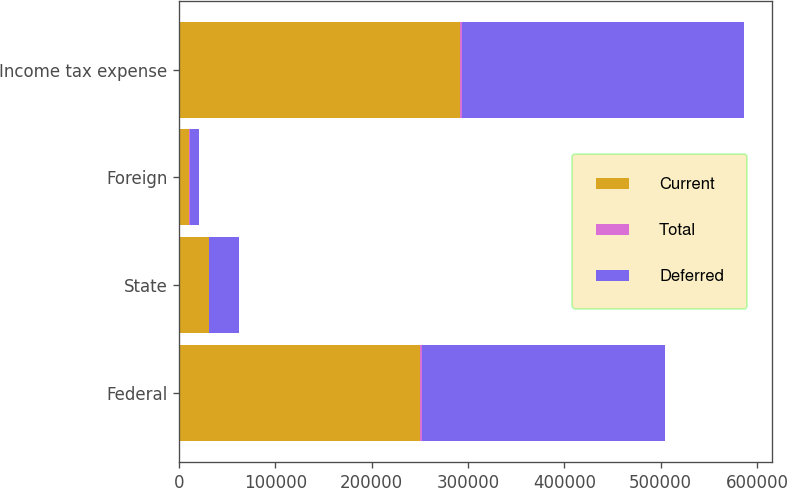Convert chart. <chart><loc_0><loc_0><loc_500><loc_500><stacked_bar_chart><ecel><fcel>Federal<fcel>State<fcel>Foreign<fcel>Income tax expense<nl><fcel>Current<fcel>250527<fcel>30768<fcel>10518<fcel>291813<nl><fcel>Total<fcel>1919<fcel>256<fcel>704<fcel>1471<nl><fcel>Deferred<fcel>252446<fcel>31024<fcel>9814<fcel>293284<nl></chart> 